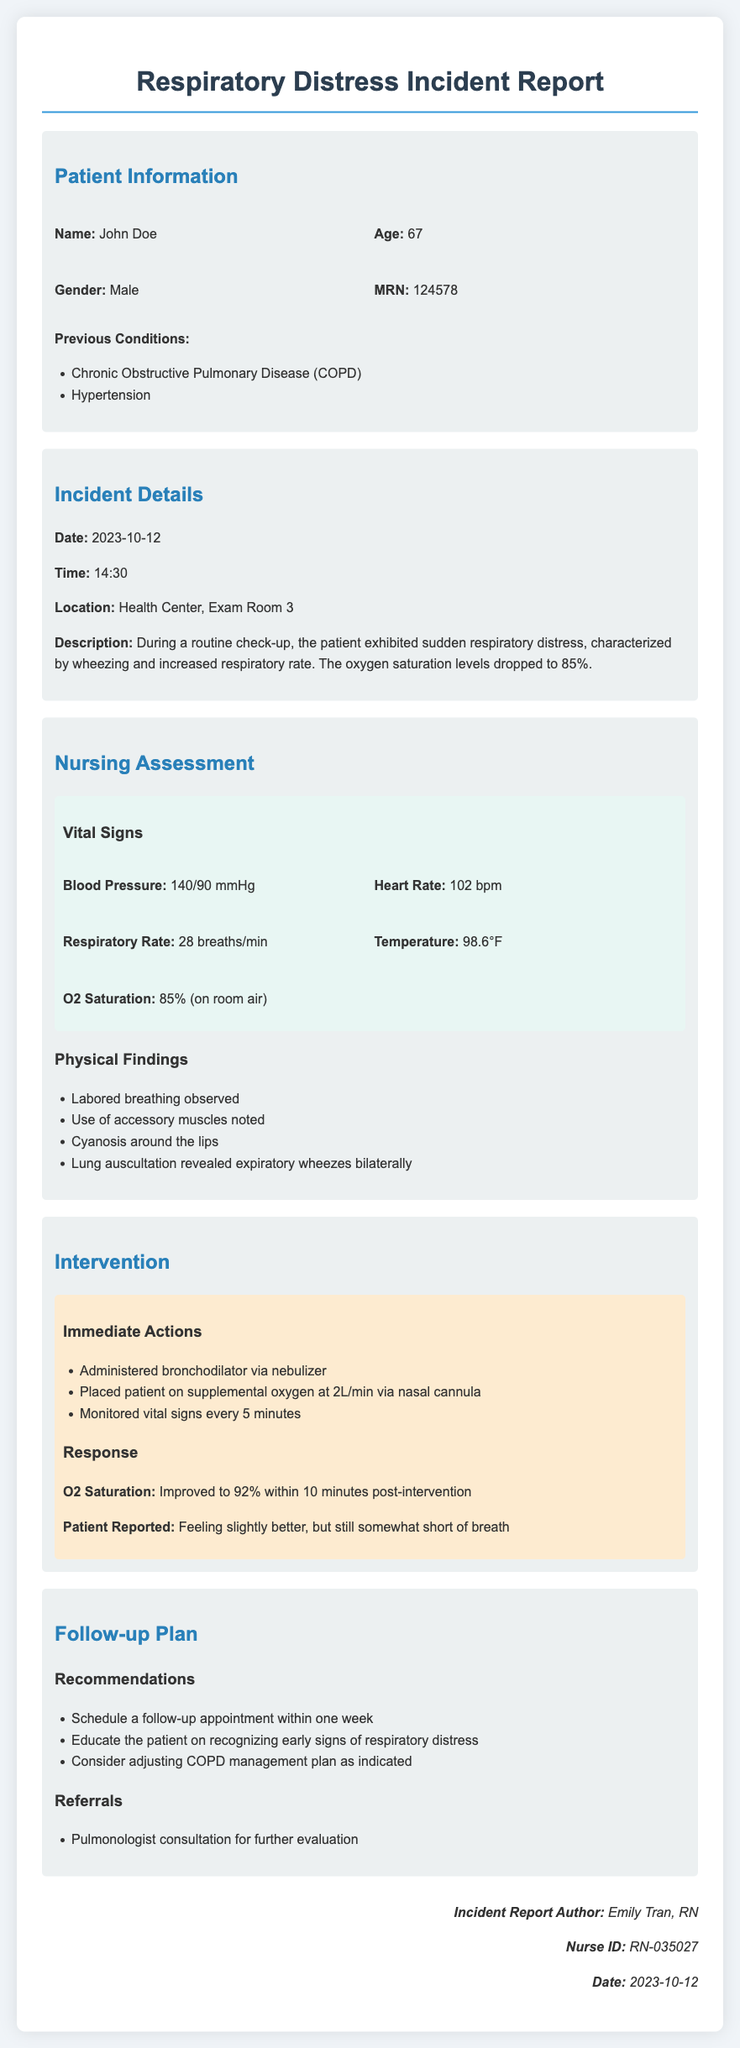What is the patient's name? The patient's name is listed in the Patient Information section of the document.
Answer: John Doe What was the patient's oxygen saturation level upon assessment? The oxygen saturation level is mentioned under Vital Signs in the Nursing Assessment section.
Answer: 85% What immediate action was taken first for the patient? The order of the actions taken is described in the Intervention section.
Answer: Administered bronchodilator via nebulizer What was the date of the incident? The incident date is specified in the Incident Details section.
Answer: 2023-10-12 What were the patient’s previous conditions? Previous conditions are outlined in the Patient Information section.
Answer: Chronic Obstructive Pulmonary Disease (COPD), Hypertension How did the patient's oxygen saturation change after the intervention? The change in oxygen saturation is reported under Response in the Intervention section.
Answer: Improved to 92% What is the recommended follow-up timeline? The follow-up timeline is mentioned in the Follow-up Plan section.
Answer: Within one week What was the patient's reported condition after the intervention? The patient's report of feelings post-intervention is detailed in the Response of the Intervention section.
Answer: Feeling slightly better, but still somewhat short of breath What is the author's name of the incident report? The author's name is found in the signature section at the document's end.
Answer: Emily Tran, RN 